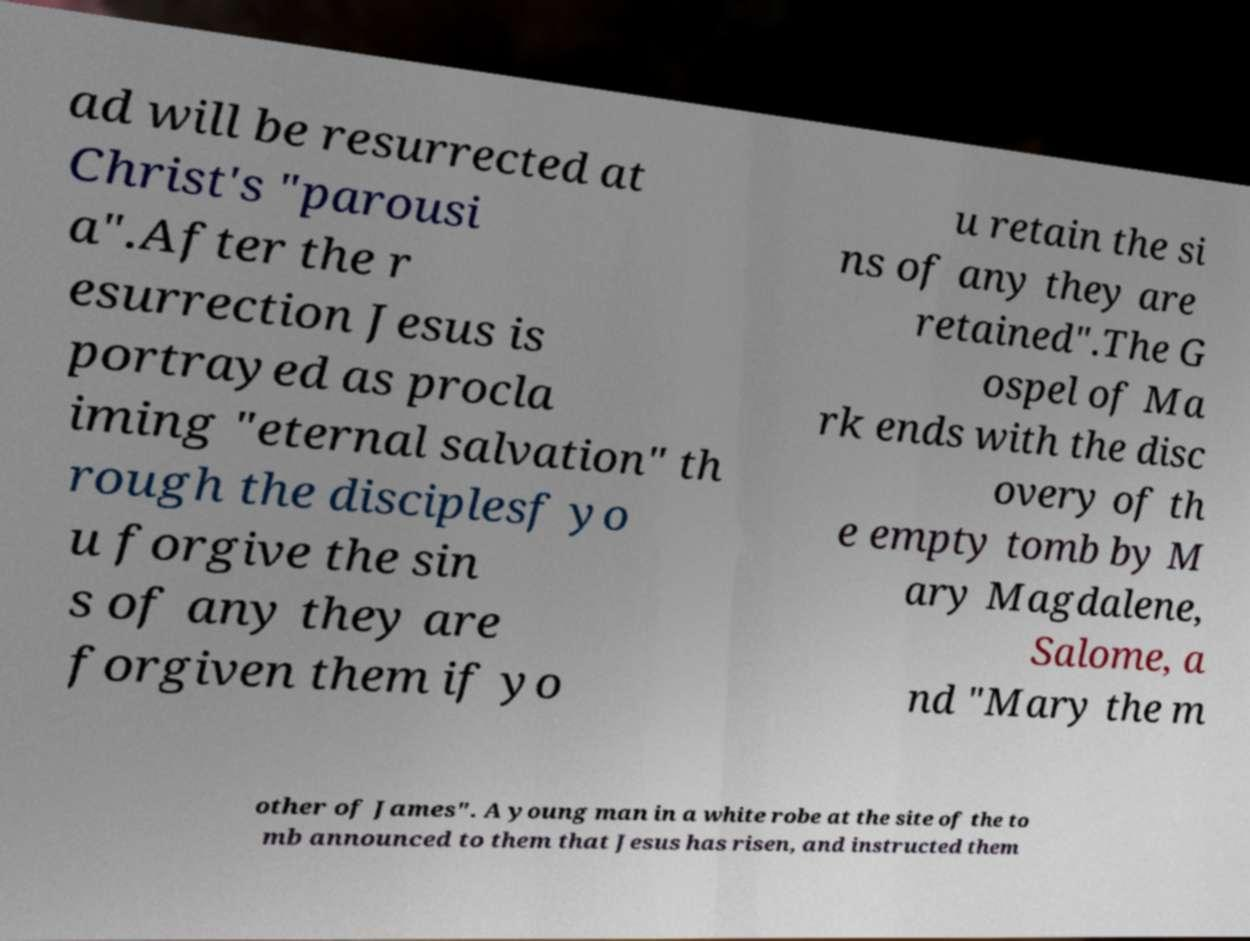Can you read and provide the text displayed in the image?This photo seems to have some interesting text. Can you extract and type it out for me? ad will be resurrected at Christ's "parousi a".After the r esurrection Jesus is portrayed as procla iming "eternal salvation" th rough the disciplesf yo u forgive the sin s of any they are forgiven them if yo u retain the si ns of any they are retained".The G ospel of Ma rk ends with the disc overy of th e empty tomb by M ary Magdalene, Salome, a nd "Mary the m other of James". A young man in a white robe at the site of the to mb announced to them that Jesus has risen, and instructed them 